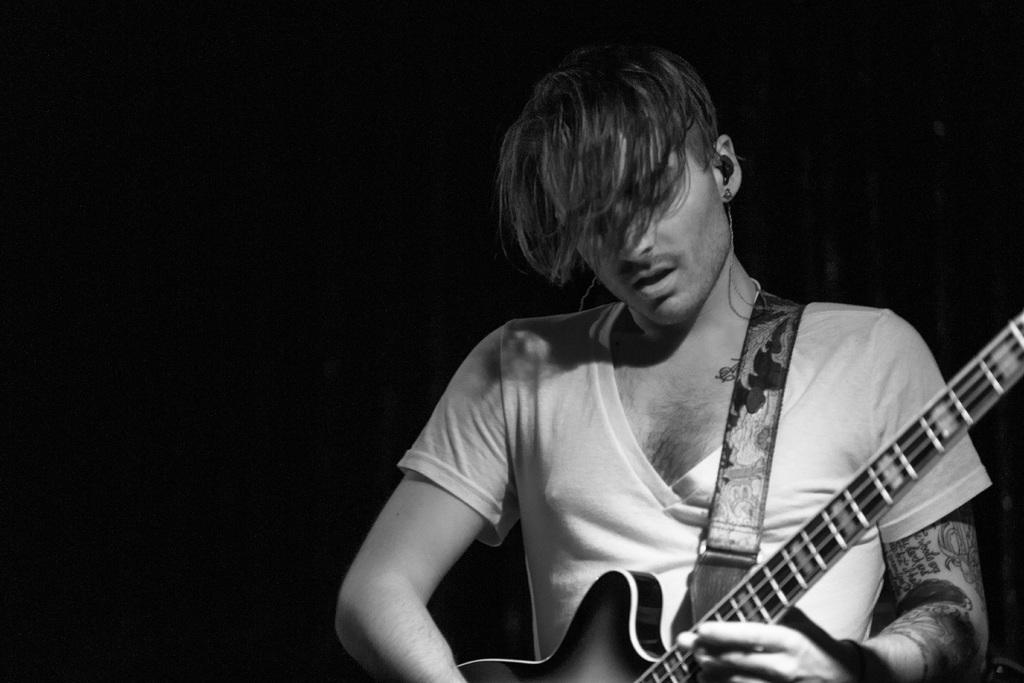Who is the main subject in the image? There is a man in the image. What is the man holding in the image? The man is holding a guitar. What is the man doing with the guitar? The man is looking at the guitar. What can be observed about the lighting in the image? The background of the image is dark. What type of mark can be seen on the man's wrist in the image? There is no mark visible on the man's wrist in the image. 